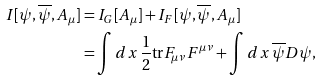<formula> <loc_0><loc_0><loc_500><loc_500>I [ \psi , \overline { \psi } , A _ { \mu } ] & = I _ { G } [ A _ { \mu } ] + I _ { F } [ \psi , \overline { \psi } , A _ { \mu } ] \\ & = \int d x \, \frac { 1 } { 2 } \text {tr} F _ { \mu \nu } F ^ { \mu \nu } + \int d x \, \overline { \psi } D \psi ,</formula> 